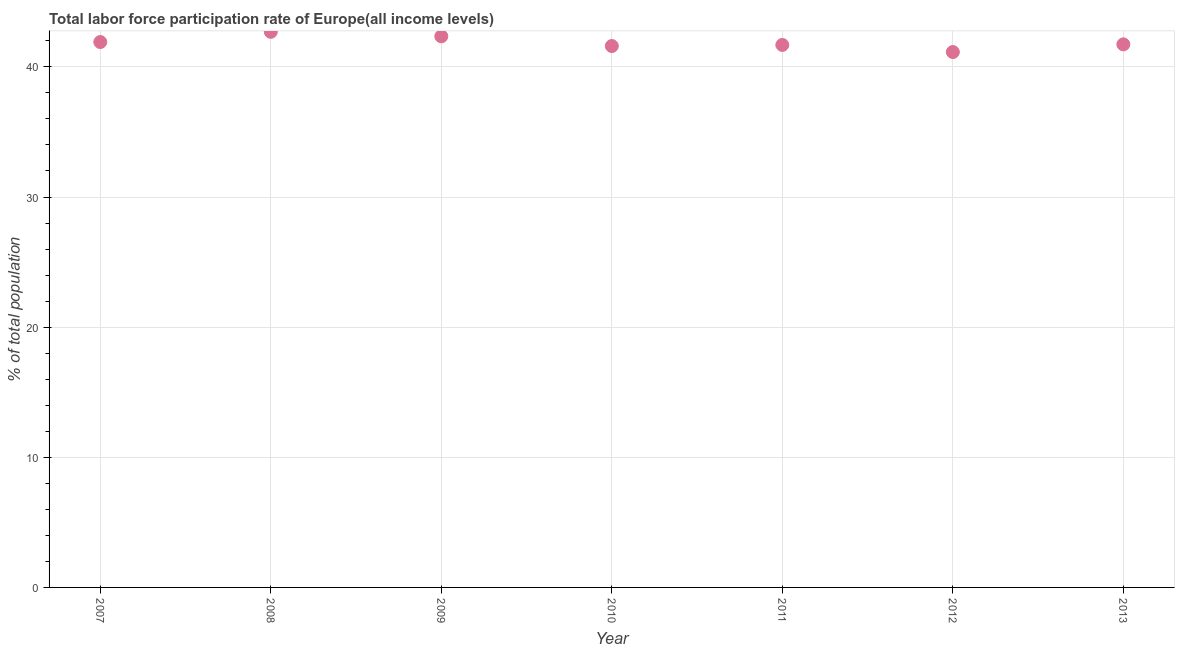What is the total labor force participation rate in 2013?
Your response must be concise. 41.73. Across all years, what is the maximum total labor force participation rate?
Keep it short and to the point. 42.69. Across all years, what is the minimum total labor force participation rate?
Make the answer very short. 41.14. In which year was the total labor force participation rate maximum?
Make the answer very short. 2008. In which year was the total labor force participation rate minimum?
Your response must be concise. 2012. What is the sum of the total labor force participation rate?
Give a very brief answer. 293.11. What is the difference between the total labor force participation rate in 2010 and 2012?
Keep it short and to the point. 0.46. What is the average total labor force participation rate per year?
Make the answer very short. 41.87. What is the median total labor force participation rate?
Give a very brief answer. 41.73. Do a majority of the years between 2013 and 2012 (inclusive) have total labor force participation rate greater than 6 %?
Give a very brief answer. No. What is the ratio of the total labor force participation rate in 2010 to that in 2012?
Give a very brief answer. 1.01. What is the difference between the highest and the second highest total labor force participation rate?
Ensure brevity in your answer.  0.34. What is the difference between the highest and the lowest total labor force participation rate?
Provide a short and direct response. 1.55. In how many years, is the total labor force participation rate greater than the average total labor force participation rate taken over all years?
Offer a very short reply. 3. Does the total labor force participation rate monotonically increase over the years?
Keep it short and to the point. No. What is the difference between two consecutive major ticks on the Y-axis?
Your answer should be very brief. 10. Are the values on the major ticks of Y-axis written in scientific E-notation?
Offer a terse response. No. Does the graph contain any zero values?
Your answer should be compact. No. What is the title of the graph?
Offer a terse response. Total labor force participation rate of Europe(all income levels). What is the label or title of the X-axis?
Your answer should be very brief. Year. What is the label or title of the Y-axis?
Offer a very short reply. % of total population. What is the % of total population in 2007?
Your answer should be compact. 41.91. What is the % of total population in 2008?
Give a very brief answer. 42.69. What is the % of total population in 2009?
Give a very brief answer. 42.35. What is the % of total population in 2010?
Your answer should be compact. 41.6. What is the % of total population in 2011?
Provide a short and direct response. 41.69. What is the % of total population in 2012?
Your answer should be very brief. 41.14. What is the % of total population in 2013?
Provide a short and direct response. 41.73. What is the difference between the % of total population in 2007 and 2008?
Keep it short and to the point. -0.78. What is the difference between the % of total population in 2007 and 2009?
Offer a terse response. -0.44. What is the difference between the % of total population in 2007 and 2010?
Make the answer very short. 0.31. What is the difference between the % of total population in 2007 and 2011?
Provide a short and direct response. 0.22. What is the difference between the % of total population in 2007 and 2012?
Provide a short and direct response. 0.77. What is the difference between the % of total population in 2007 and 2013?
Make the answer very short. 0.18. What is the difference between the % of total population in 2008 and 2009?
Ensure brevity in your answer.  0.34. What is the difference between the % of total population in 2008 and 2010?
Offer a terse response. 1.09. What is the difference between the % of total population in 2008 and 2011?
Offer a terse response. 1.01. What is the difference between the % of total population in 2008 and 2012?
Ensure brevity in your answer.  1.55. What is the difference between the % of total population in 2008 and 2013?
Offer a very short reply. 0.96. What is the difference between the % of total population in 2009 and 2010?
Your response must be concise. 0.75. What is the difference between the % of total population in 2009 and 2011?
Provide a short and direct response. 0.66. What is the difference between the % of total population in 2009 and 2012?
Ensure brevity in your answer.  1.21. What is the difference between the % of total population in 2009 and 2013?
Ensure brevity in your answer.  0.62. What is the difference between the % of total population in 2010 and 2011?
Keep it short and to the point. -0.08. What is the difference between the % of total population in 2010 and 2012?
Your response must be concise. 0.46. What is the difference between the % of total population in 2010 and 2013?
Provide a succinct answer. -0.13. What is the difference between the % of total population in 2011 and 2012?
Your response must be concise. 0.55. What is the difference between the % of total population in 2011 and 2013?
Give a very brief answer. -0.05. What is the difference between the % of total population in 2012 and 2013?
Offer a very short reply. -0.59. What is the ratio of the % of total population in 2007 to that in 2010?
Offer a very short reply. 1.01. What is the ratio of the % of total population in 2007 to that in 2011?
Offer a terse response. 1. What is the ratio of the % of total population in 2007 to that in 2013?
Ensure brevity in your answer.  1. What is the ratio of the % of total population in 2008 to that in 2012?
Provide a succinct answer. 1.04. What is the ratio of the % of total population in 2008 to that in 2013?
Your response must be concise. 1.02. What is the ratio of the % of total population in 2009 to that in 2011?
Your answer should be very brief. 1.02. What is the ratio of the % of total population in 2009 to that in 2012?
Your response must be concise. 1.03. What is the ratio of the % of total population in 2010 to that in 2013?
Ensure brevity in your answer.  1. What is the ratio of the % of total population in 2011 to that in 2013?
Provide a short and direct response. 1. What is the ratio of the % of total population in 2012 to that in 2013?
Your answer should be compact. 0.99. 